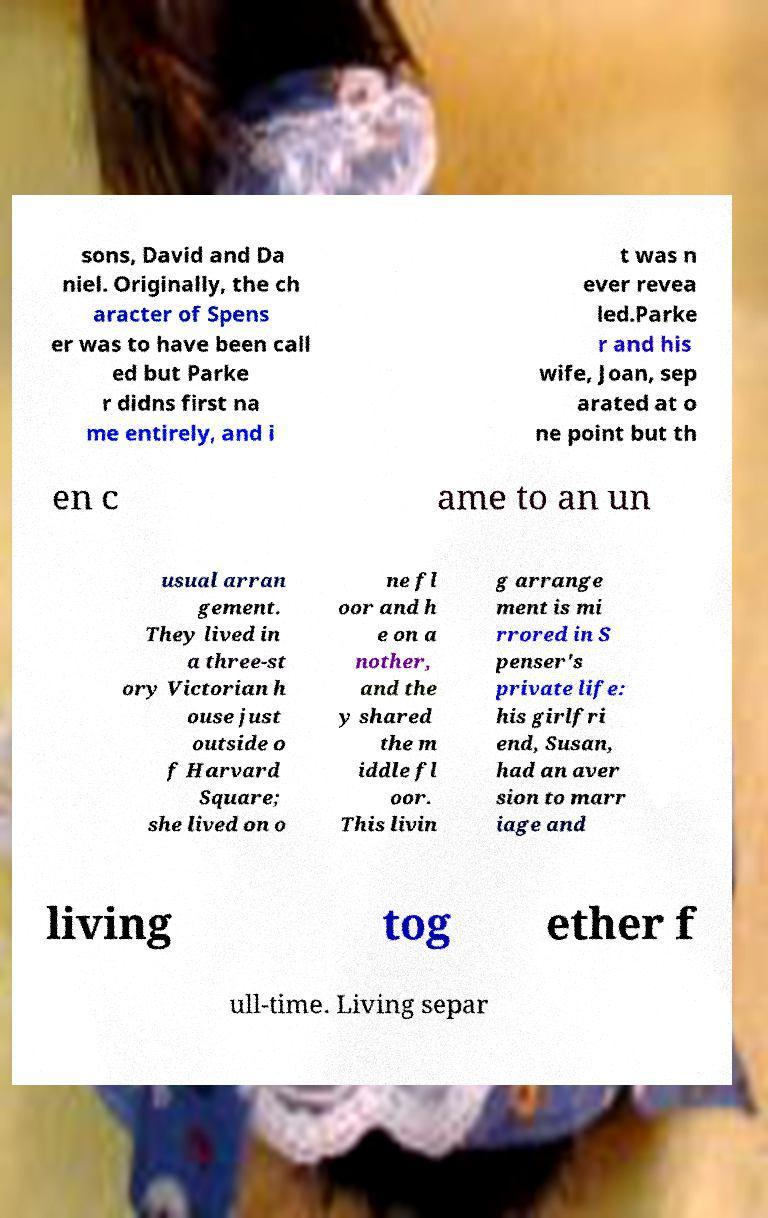For documentation purposes, I need the text within this image transcribed. Could you provide that? sons, David and Da niel. Originally, the ch aracter of Spens er was to have been call ed but Parke r didns first na me entirely, and i t was n ever revea led.Parke r and his wife, Joan, sep arated at o ne point but th en c ame to an un usual arran gement. They lived in a three-st ory Victorian h ouse just outside o f Harvard Square; she lived on o ne fl oor and h e on a nother, and the y shared the m iddle fl oor. This livin g arrange ment is mi rrored in S penser's private life: his girlfri end, Susan, had an aver sion to marr iage and living tog ether f ull-time. Living separ 